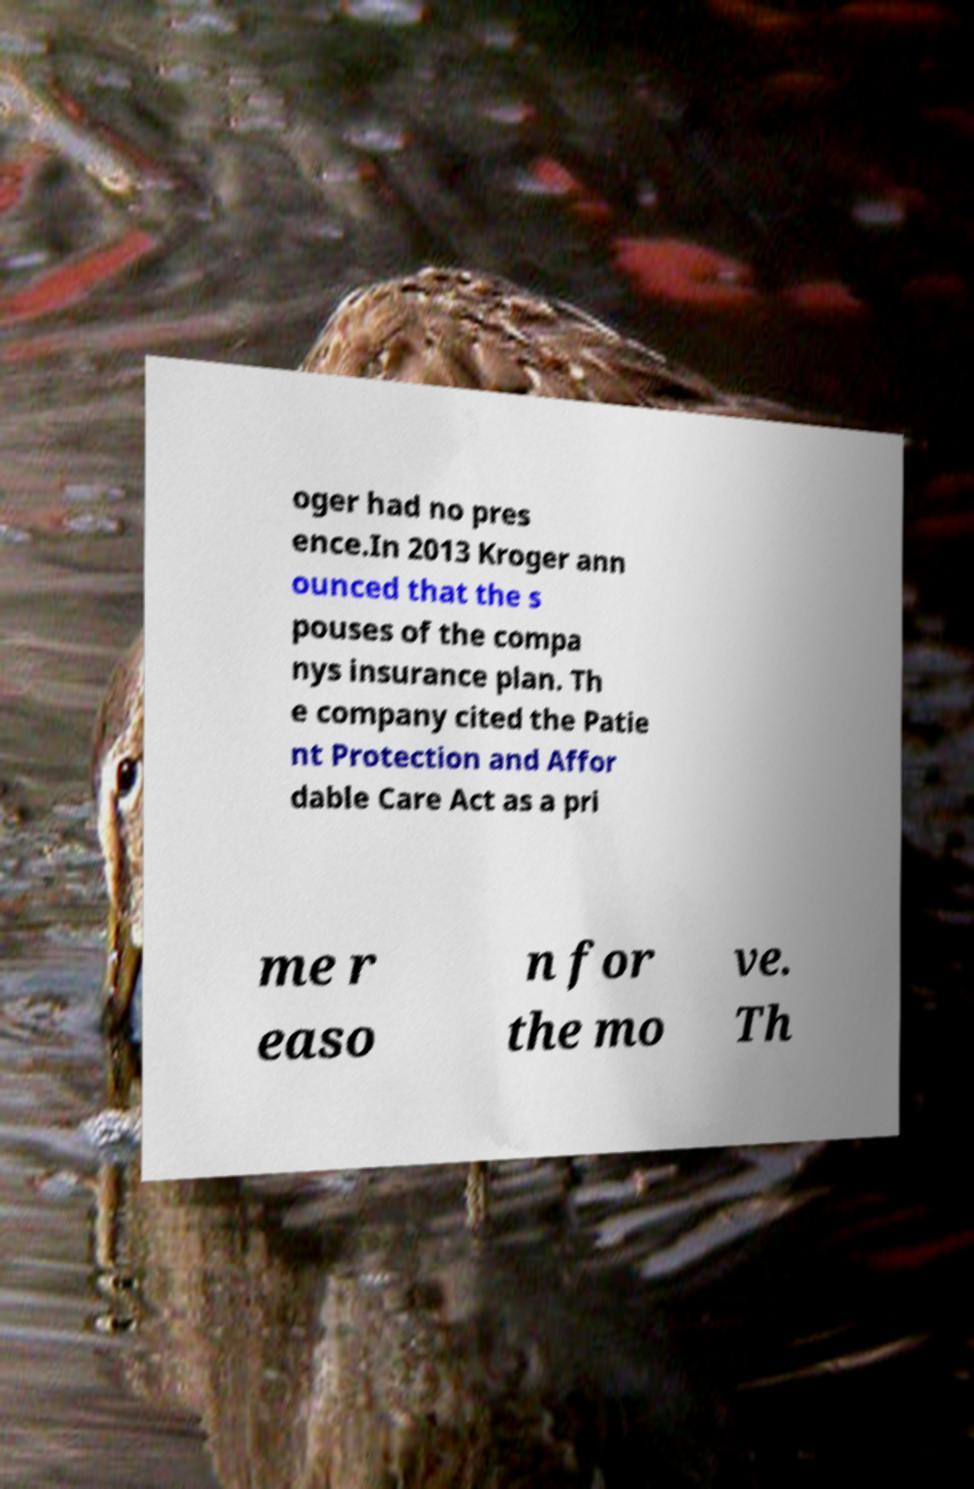Could you extract and type out the text from this image? oger had no pres ence.In 2013 Kroger ann ounced that the s pouses of the compa nys insurance plan. Th e company cited the Patie nt Protection and Affor dable Care Act as a pri me r easo n for the mo ve. Th 